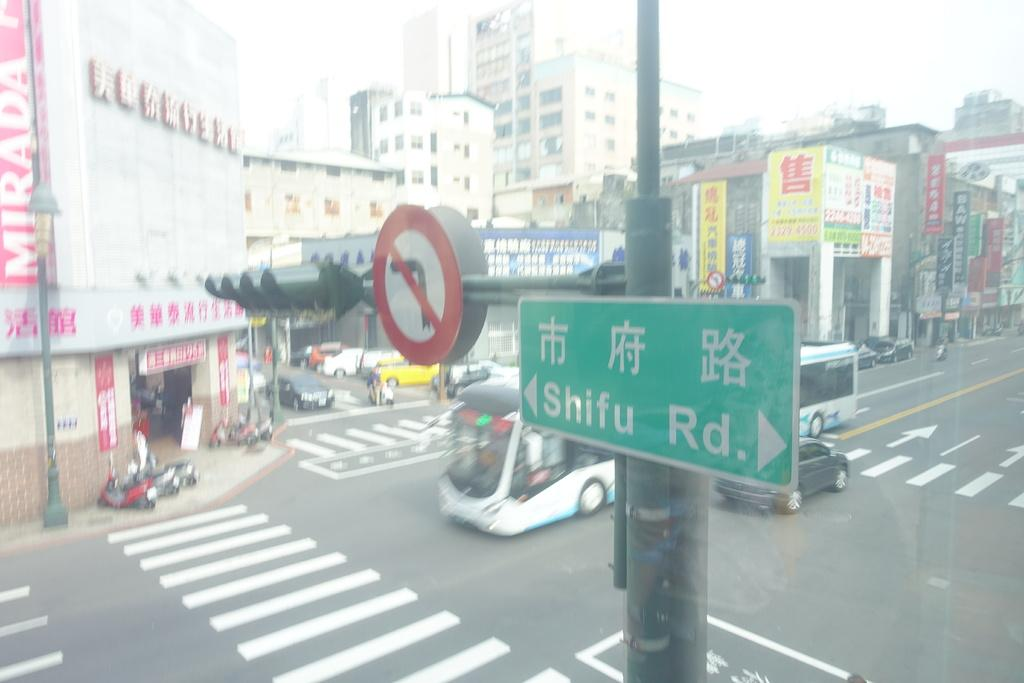<image>
Write a terse but informative summary of the picture. the word shifu that is on a green street sign 